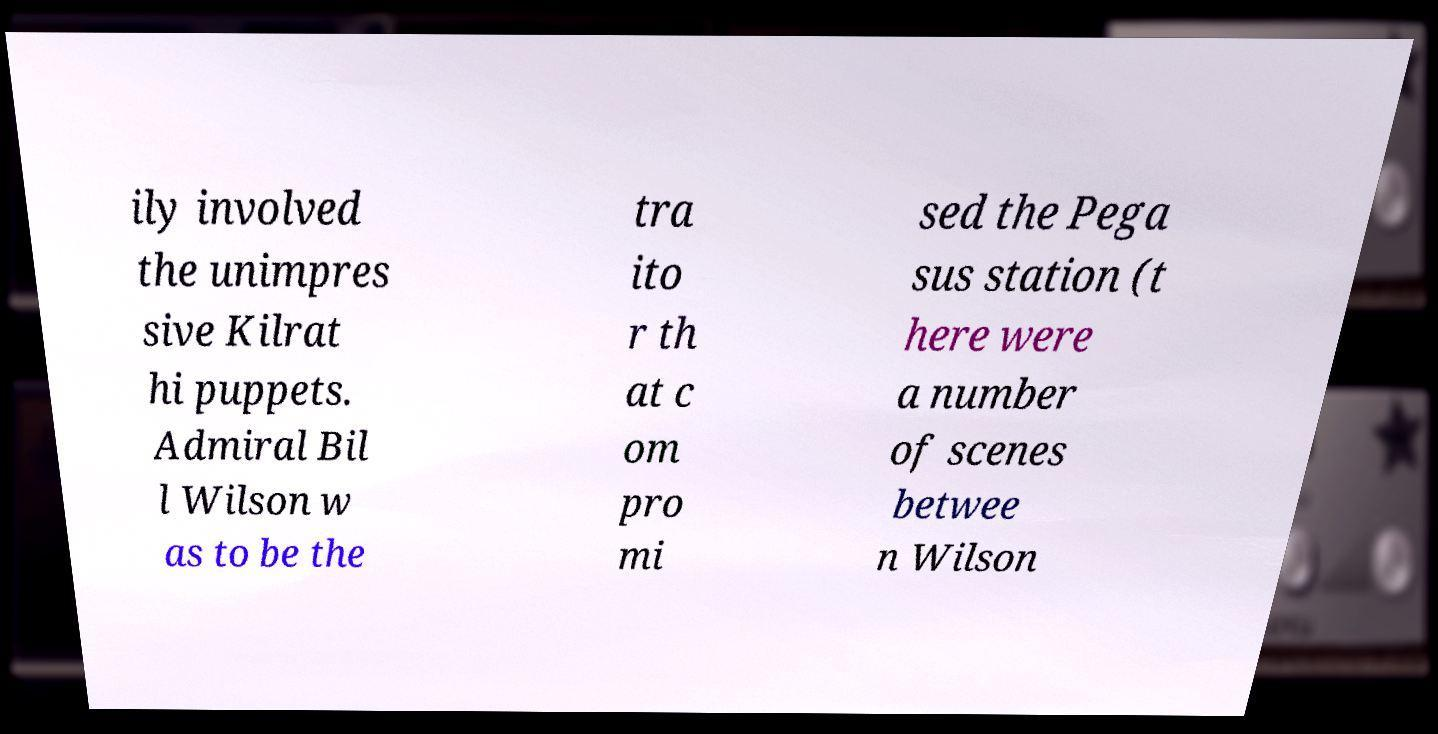What messages or text are displayed in this image? I need them in a readable, typed format. ily involved the unimpres sive Kilrat hi puppets. Admiral Bil l Wilson w as to be the tra ito r th at c om pro mi sed the Pega sus station (t here were a number of scenes betwee n Wilson 